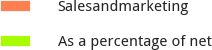<chart> <loc_0><loc_0><loc_500><loc_500><pie_chart><fcel>Salesandmarketing<fcel>As a percentage of net<nl><fcel>100.0%<fcel>0.0%<nl></chart> 